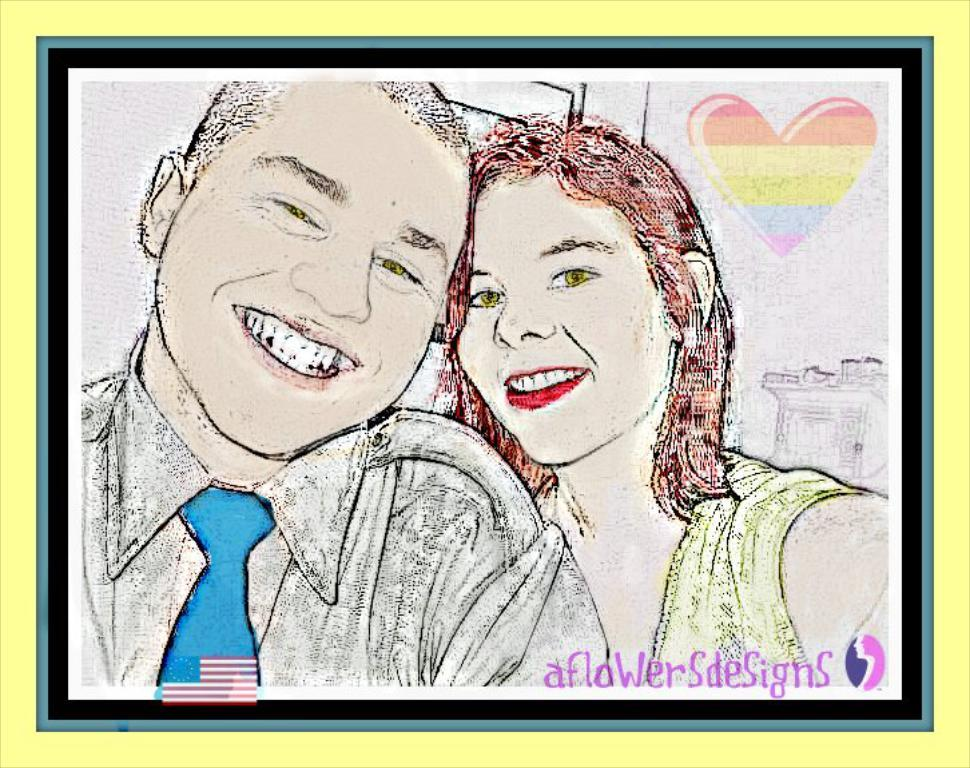What is the emotional expression of the man in the image? The man is smiling in the image. What is the emotional expression of the woman in the image? The woman is also smiling in the image. Can you describe any additional elements in the background of the image? Yes, there is a heart sticker in the background of the image. What type of grain is visible on the floor in the image? There is no floor or grain present in the image. How many bottles can be seen in the image? There are no bottles visible in the image. 